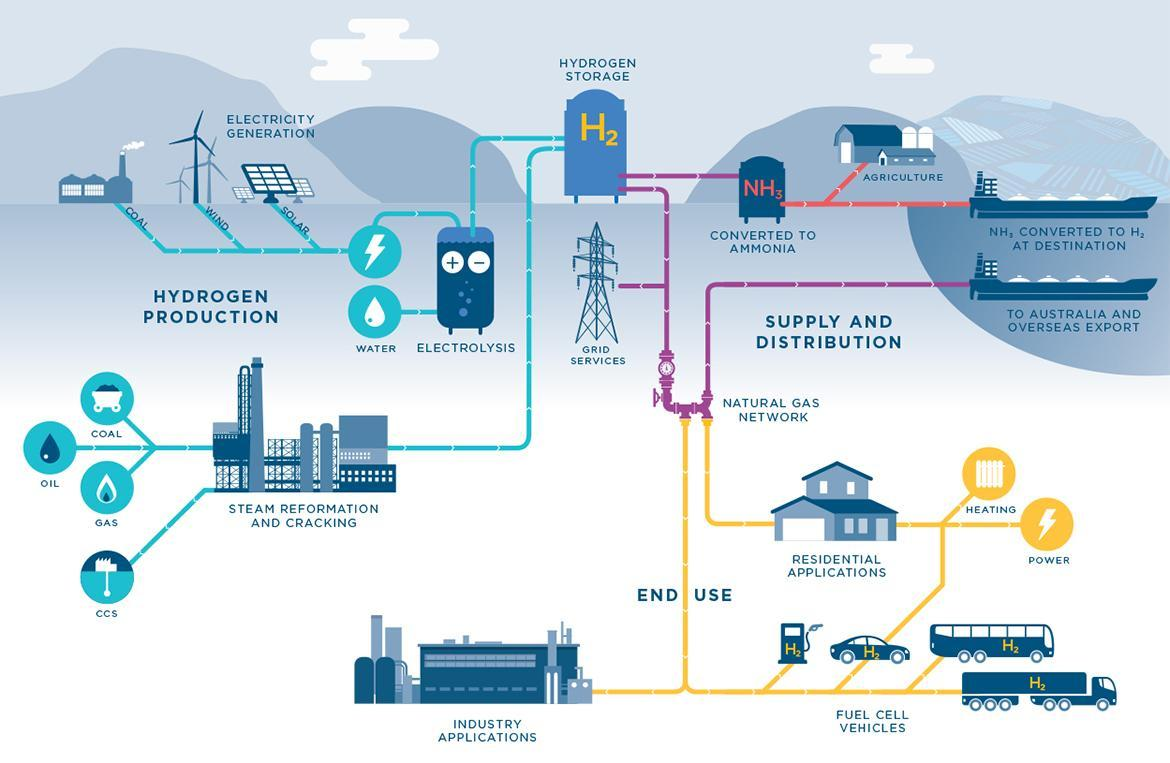What is the chemical formula for Ammonia?
Answer the question with a short phrase. NH3 In what form is Hydrogen used in agriculture? Ammonia Which gas is required for heating a residence? H2 What are used for hydrogen production? Coal,wind,solar 